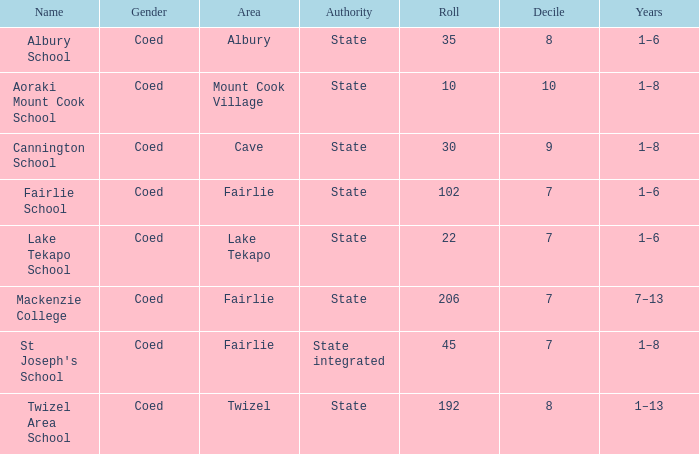What is the total Decile that has a state authority, fairlie area and roll smarter than 206? 1.0. 